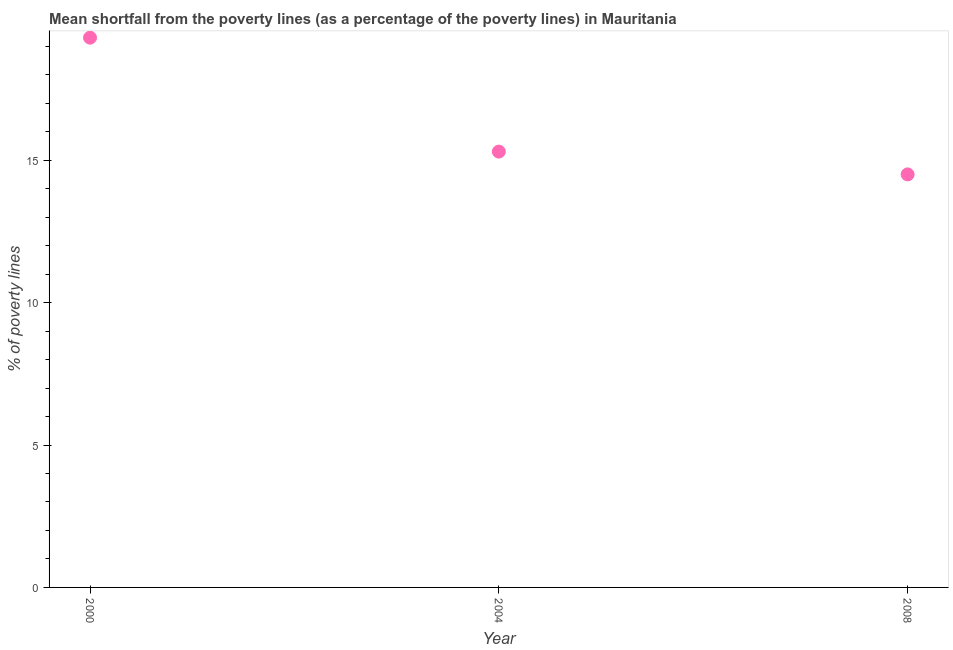Across all years, what is the maximum poverty gap at national poverty lines?
Provide a succinct answer. 19.3. In which year was the poverty gap at national poverty lines maximum?
Offer a very short reply. 2000. In which year was the poverty gap at national poverty lines minimum?
Make the answer very short. 2008. What is the sum of the poverty gap at national poverty lines?
Give a very brief answer. 49.1. What is the difference between the poverty gap at national poverty lines in 2000 and 2008?
Offer a terse response. 4.8. What is the average poverty gap at national poverty lines per year?
Offer a very short reply. 16.37. What is the ratio of the poverty gap at national poverty lines in 2000 to that in 2008?
Provide a succinct answer. 1.33. Is the sum of the poverty gap at national poverty lines in 2000 and 2008 greater than the maximum poverty gap at national poverty lines across all years?
Your answer should be compact. Yes. What is the difference between the highest and the lowest poverty gap at national poverty lines?
Your answer should be very brief. 4.8. In how many years, is the poverty gap at national poverty lines greater than the average poverty gap at national poverty lines taken over all years?
Your response must be concise. 1. How many dotlines are there?
Keep it short and to the point. 1. Does the graph contain any zero values?
Your response must be concise. No. What is the title of the graph?
Offer a terse response. Mean shortfall from the poverty lines (as a percentage of the poverty lines) in Mauritania. What is the label or title of the X-axis?
Your answer should be very brief. Year. What is the label or title of the Y-axis?
Make the answer very short. % of poverty lines. What is the % of poverty lines in 2000?
Provide a succinct answer. 19.3. What is the % of poverty lines in 2004?
Keep it short and to the point. 15.3. What is the difference between the % of poverty lines in 2000 and 2004?
Ensure brevity in your answer.  4. What is the difference between the % of poverty lines in 2000 and 2008?
Provide a succinct answer. 4.8. What is the difference between the % of poverty lines in 2004 and 2008?
Your response must be concise. 0.8. What is the ratio of the % of poverty lines in 2000 to that in 2004?
Your answer should be very brief. 1.26. What is the ratio of the % of poverty lines in 2000 to that in 2008?
Provide a succinct answer. 1.33. What is the ratio of the % of poverty lines in 2004 to that in 2008?
Make the answer very short. 1.05. 